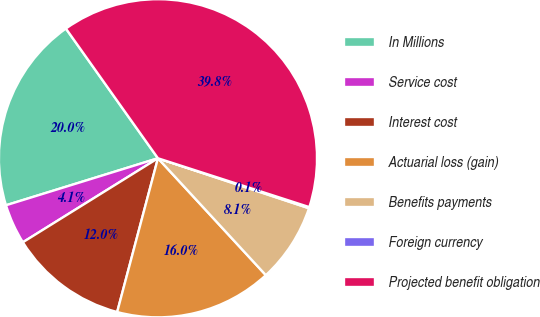Convert chart to OTSL. <chart><loc_0><loc_0><loc_500><loc_500><pie_chart><fcel>In Millions<fcel>Service cost<fcel>Interest cost<fcel>Actuarial loss (gain)<fcel>Benefits payments<fcel>Foreign currency<fcel>Projected benefit obligation<nl><fcel>19.95%<fcel>4.08%<fcel>12.02%<fcel>15.99%<fcel>8.05%<fcel>0.12%<fcel>39.79%<nl></chart> 